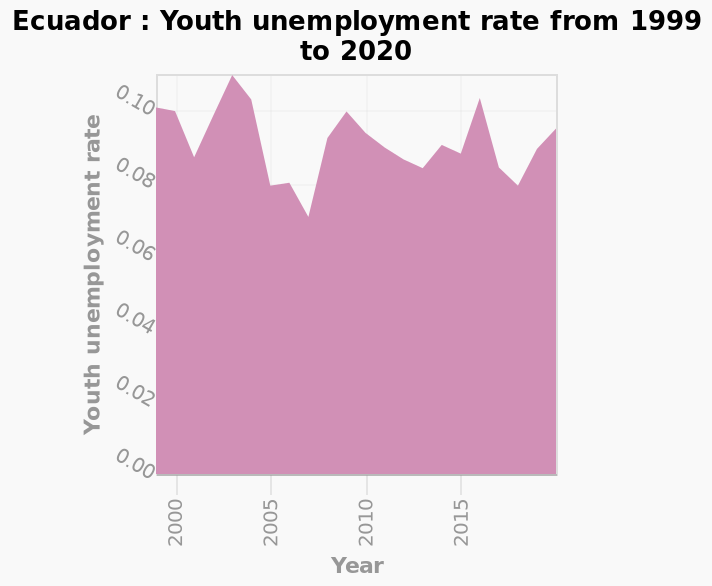<image>
What was the year with the largest average number of daily Sun hours?  2003 What specific data does the graph show? The graph shows the Youth unemployment rate in Ecuador over the years 1999 to 2020. 